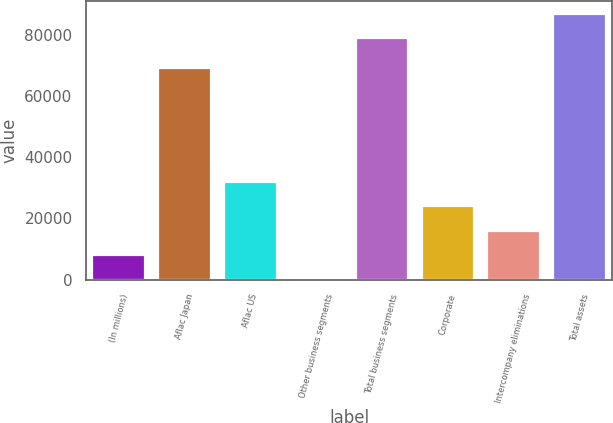<chart> <loc_0><loc_0><loc_500><loc_500><bar_chart><fcel>(In millions)<fcel>Aflac Japan<fcel>Aflac US<fcel>Other business segments<fcel>Total business segments<fcel>Corporate<fcel>Intercompany eliminations<fcel>Total assets<nl><fcel>8082.5<fcel>69141<fcel>31832<fcel>166<fcel>78986<fcel>23915.5<fcel>15999<fcel>86902.5<nl></chart> 